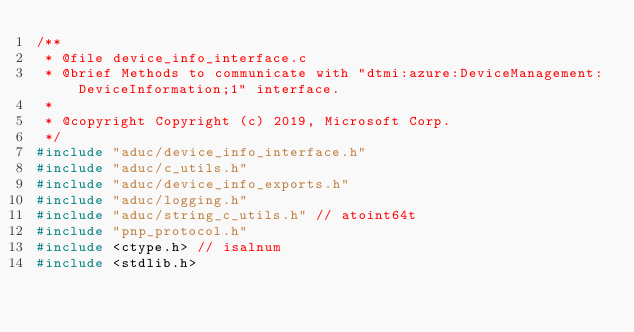Convert code to text. <code><loc_0><loc_0><loc_500><loc_500><_C_>/**
 * @file device_info_interface.c
 * @brief Methods to communicate with "dtmi:azure:DeviceManagement:DeviceInformation;1" interface.
 *
 * @copyright Copyright (c) 2019, Microsoft Corp.
 */
#include "aduc/device_info_interface.h"
#include "aduc/c_utils.h"
#include "aduc/device_info_exports.h"
#include "aduc/logging.h"
#include "aduc/string_c_utils.h" // atoint64t
#include "pnp_protocol.h"
#include <ctype.h> // isalnum
#include <stdlib.h>
</code> 